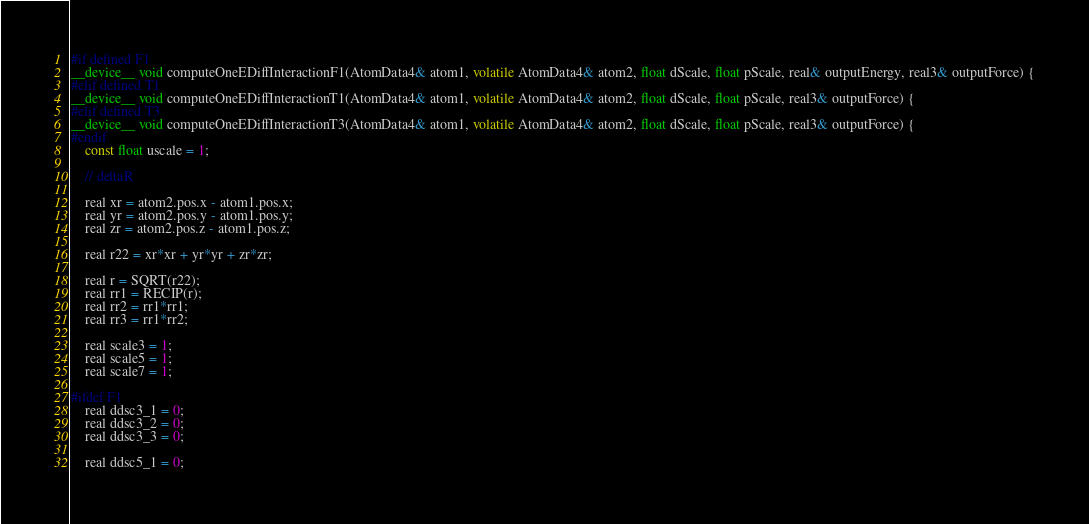Convert code to text. <code><loc_0><loc_0><loc_500><loc_500><_Cuda_>#if defined F1
__device__ void computeOneEDiffInteractionF1(AtomData4& atom1, volatile AtomData4& atom2, float dScale, float pScale, real& outputEnergy, real3& outputForce) {
#elif defined T1
__device__ void computeOneEDiffInteractionT1(AtomData4& atom1, volatile AtomData4& atom2, float dScale, float pScale, real3& outputForce) {
#elif defined T3
__device__ void computeOneEDiffInteractionT3(AtomData4& atom1, volatile AtomData4& atom2, float dScale, float pScale, real3& outputForce) {
#endif
    const float uscale = 1;

    // deltaR

    real xr = atom2.pos.x - atom1.pos.x;
    real yr = atom2.pos.y - atom1.pos.y;
    real zr = atom2.pos.z - atom1.pos.z;

    real r22 = xr*xr + yr*yr + zr*zr;

    real r = SQRT(r22);
    real rr1 = RECIP(r);
    real rr2 = rr1*rr1;
    real rr3 = rr1*rr2;

    real scale3 = 1;
    real scale5 = 1;
    real scale7 = 1;

#ifdef F1
    real ddsc3_1 = 0;
    real ddsc3_2 = 0;
    real ddsc3_3 = 0;

    real ddsc5_1 = 0;</code> 